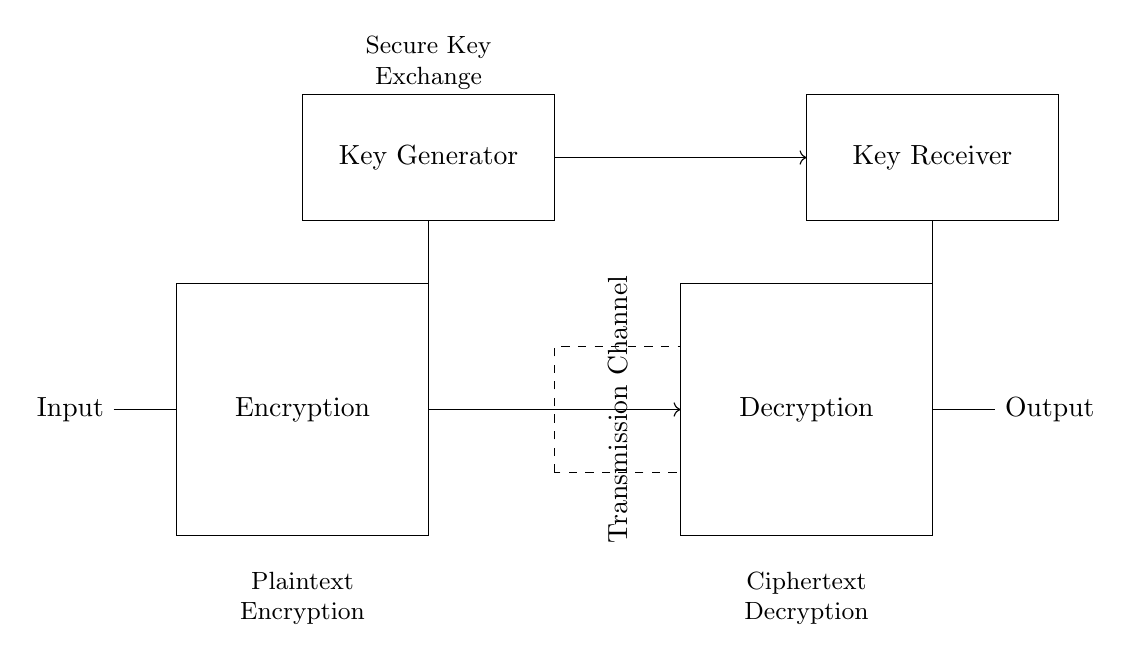What does the encryption block represent? The encryption block represents the process where plaintext is transformed into ciphertext using cryptographic algorithms, ensuring secure communication.
Answer: Encryption What is the purpose of the key generator? The key generator's purpose is to create secure cryptographic keys required for the encryption process, facilitating the transformation of data.
Answer: Secure key creation How are the input and output related in this circuit? The input is the plaintext that is processed by the encryption block, and the output is the resulting ciphertext after decryption, showcasing the relationship between encrypted and decrypted data.
Answer: Transformation process What type of system is being represented here? This circuit represents a digital encryption system, designed for secure communication between parties using cryptography.
Answer: Digital encryption system What is the function of the transmission channel? The transmission channel serves to carry the encrypted data (ciphertext) from the encryption block to the decryption block, ensuring data moves securely over a medium.
Answer: Carrying ciphertext 